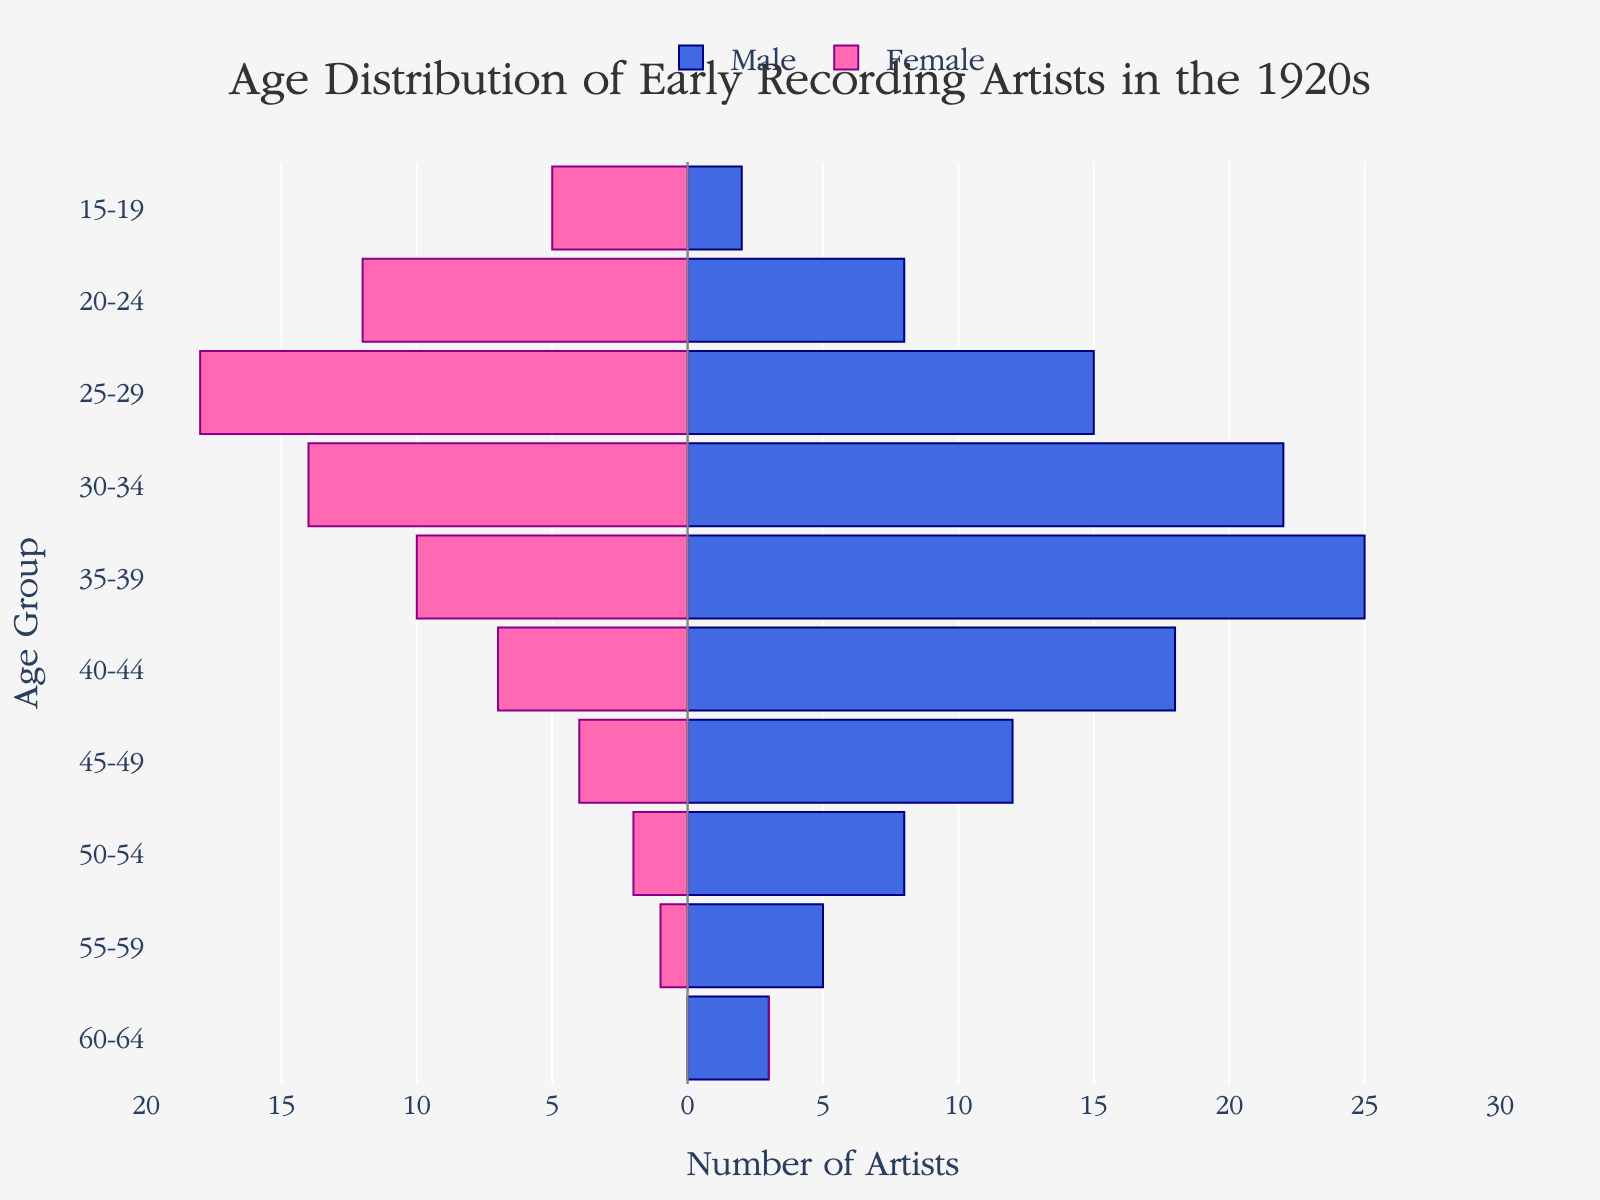What is the title of the figure? The title of the figure is located at the top center and provides a summary of what the figure represents.
Answer: Age Distribution of Early Recording Artists in the 1920s Which age group has the highest number of male performers? Look for the longest bar on the right-hand side (representing male performers) and find the corresponding age group on the y-axis.
Answer: 35-39 Which age group has the highest number of female performers? Look for the longest bar on the left-hand side (representing female performers) and find the corresponding age group on the y-axis.
Answer: 25-29 How many male performers are there in the 40-44 age group? Identify the bar corresponding to the 40-44 age group on the right-hand side, and read the value.
Answer: 18 How many female performers are there in the 15-19 age group? Identify the bar corresponding to the 15-19 age group on the left-hand side, and read the value.
Answer: 5 What is the combined number of male and female performers in the 45-49 age group? Add the number of male performers (12) and female performers (4) in the 45-49 age group.
Answer: 16 How does the number of performers in the 50-54 age group compare between males and females? Look at the length of the bars for the 50-54 age group on both sides and compare. The male bar is longer.
Answer: More males In which age groups are there no female performers? Look for bars on the left-hand side that have a length of 0 and check their corresponding age groups on the y-axis.
Answer: 60-64 What trend do you observe in the number of male performers as the age increases? Observe how the lengths of the right-side bars change as you move from the youngest to the oldest age groups. The number of male performers generally decreases with age.
Answer: Decreasing Are there more male or female performers in the 30-34 age group? Compare the lengths of the bars for the 30-34 age group on both sides.
Answer: More males 